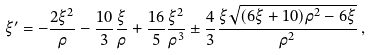Convert formula to latex. <formula><loc_0><loc_0><loc_500><loc_500>\xi ^ { \prime } = - { \frac { 2 \xi ^ { 2 } } { \rho } } - \frac { 1 0 } 3 { \frac { \xi } { \rho } } + { \frac { 1 6 } { 5 } } { \frac { \xi ^ { 2 } } { { \rho } ^ { 3 } } } \pm \frac { 4 } { 3 } { \frac { \xi \sqrt { ( 6 \xi + 1 0 ) { \rho } ^ { 2 } - 6 \xi } } { { \rho } ^ { 2 } } } \, ,</formula> 